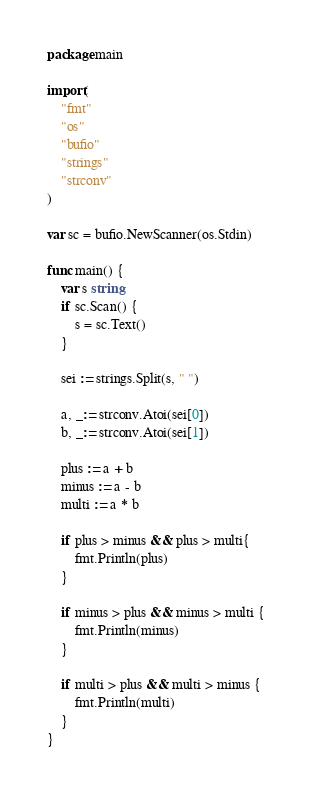Convert code to text. <code><loc_0><loc_0><loc_500><loc_500><_Go_>package main

import(
	"fmt"
	"os"
	"bufio"
	"strings"
	"strconv"
)

var sc = bufio.NewScanner(os.Stdin)

func main() {
	var s string
	if sc.Scan() {
		s = sc.Text()
	}

	sei := strings.Split(s, " ")

	a, _:= strconv.Atoi(sei[0])
	b, _:= strconv.Atoi(sei[1])

	plus := a + b
	minus := a - b
	multi := a * b

	if plus > minus && plus > multi{
		fmt.Println(plus)
	}

	if minus > plus && minus > multi {
		fmt.Println(minus)
	}

	if multi > plus && multi > minus {
		fmt.Println(multi)
	}
}</code> 